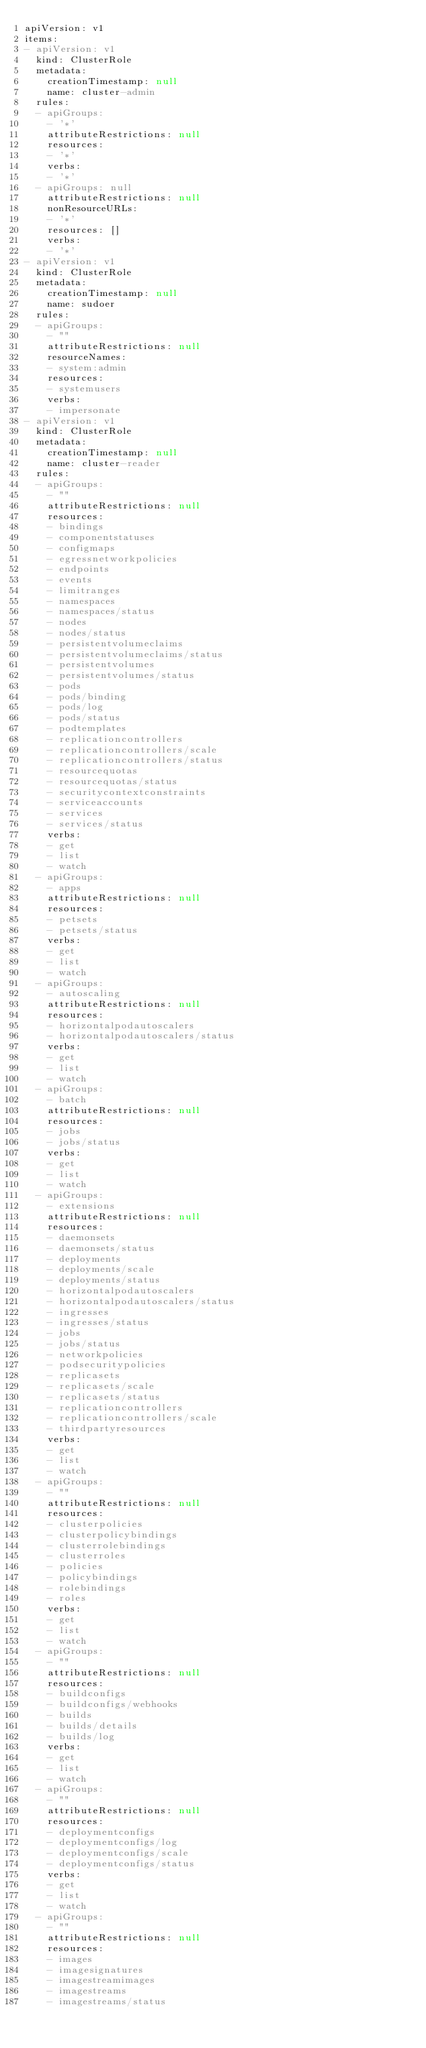<code> <loc_0><loc_0><loc_500><loc_500><_YAML_>apiVersion: v1
items:
- apiVersion: v1
  kind: ClusterRole
  metadata:
    creationTimestamp: null
    name: cluster-admin
  rules:
  - apiGroups:
    - '*'
    attributeRestrictions: null
    resources:
    - '*'
    verbs:
    - '*'
  - apiGroups: null
    attributeRestrictions: null
    nonResourceURLs:
    - '*'
    resources: []
    verbs:
    - '*'
- apiVersion: v1
  kind: ClusterRole
  metadata:
    creationTimestamp: null
    name: sudoer
  rules:
  - apiGroups:
    - ""
    attributeRestrictions: null
    resourceNames:
    - system:admin
    resources:
    - systemusers
    verbs:
    - impersonate
- apiVersion: v1
  kind: ClusterRole
  metadata:
    creationTimestamp: null
    name: cluster-reader
  rules:
  - apiGroups:
    - ""
    attributeRestrictions: null
    resources:
    - bindings
    - componentstatuses
    - configmaps
    - egressnetworkpolicies
    - endpoints
    - events
    - limitranges
    - namespaces
    - namespaces/status
    - nodes
    - nodes/status
    - persistentvolumeclaims
    - persistentvolumeclaims/status
    - persistentvolumes
    - persistentvolumes/status
    - pods
    - pods/binding
    - pods/log
    - pods/status
    - podtemplates
    - replicationcontrollers
    - replicationcontrollers/scale
    - replicationcontrollers/status
    - resourcequotas
    - resourcequotas/status
    - securitycontextconstraints
    - serviceaccounts
    - services
    - services/status
    verbs:
    - get
    - list
    - watch
  - apiGroups:
    - apps
    attributeRestrictions: null
    resources:
    - petsets
    - petsets/status
    verbs:
    - get
    - list
    - watch
  - apiGroups:
    - autoscaling
    attributeRestrictions: null
    resources:
    - horizontalpodautoscalers
    - horizontalpodautoscalers/status
    verbs:
    - get
    - list
    - watch
  - apiGroups:
    - batch
    attributeRestrictions: null
    resources:
    - jobs
    - jobs/status
    verbs:
    - get
    - list
    - watch
  - apiGroups:
    - extensions
    attributeRestrictions: null
    resources:
    - daemonsets
    - daemonsets/status
    - deployments
    - deployments/scale
    - deployments/status
    - horizontalpodautoscalers
    - horizontalpodautoscalers/status
    - ingresses
    - ingresses/status
    - jobs
    - jobs/status
    - networkpolicies
    - podsecuritypolicies
    - replicasets
    - replicasets/scale
    - replicasets/status
    - replicationcontrollers
    - replicationcontrollers/scale
    - thirdpartyresources
    verbs:
    - get
    - list
    - watch
  - apiGroups:
    - ""
    attributeRestrictions: null
    resources:
    - clusterpolicies
    - clusterpolicybindings
    - clusterrolebindings
    - clusterroles
    - policies
    - policybindings
    - rolebindings
    - roles
    verbs:
    - get
    - list
    - watch
  - apiGroups:
    - ""
    attributeRestrictions: null
    resources:
    - buildconfigs
    - buildconfigs/webhooks
    - builds
    - builds/details
    - builds/log
    verbs:
    - get
    - list
    - watch
  - apiGroups:
    - ""
    attributeRestrictions: null
    resources:
    - deploymentconfigs
    - deploymentconfigs/log
    - deploymentconfigs/scale
    - deploymentconfigs/status
    verbs:
    - get
    - list
    - watch
  - apiGroups:
    - ""
    attributeRestrictions: null
    resources:
    - images
    - imagesignatures
    - imagestreamimages
    - imagestreams
    - imagestreams/status</code> 